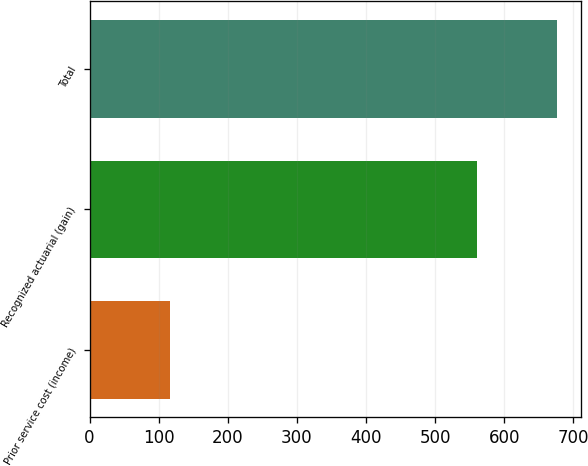Convert chart to OTSL. <chart><loc_0><loc_0><loc_500><loc_500><bar_chart><fcel>Prior service cost (income)<fcel>Recognized actuarial (gain)<fcel>Total<nl><fcel>116<fcel>561<fcel>677<nl></chart> 